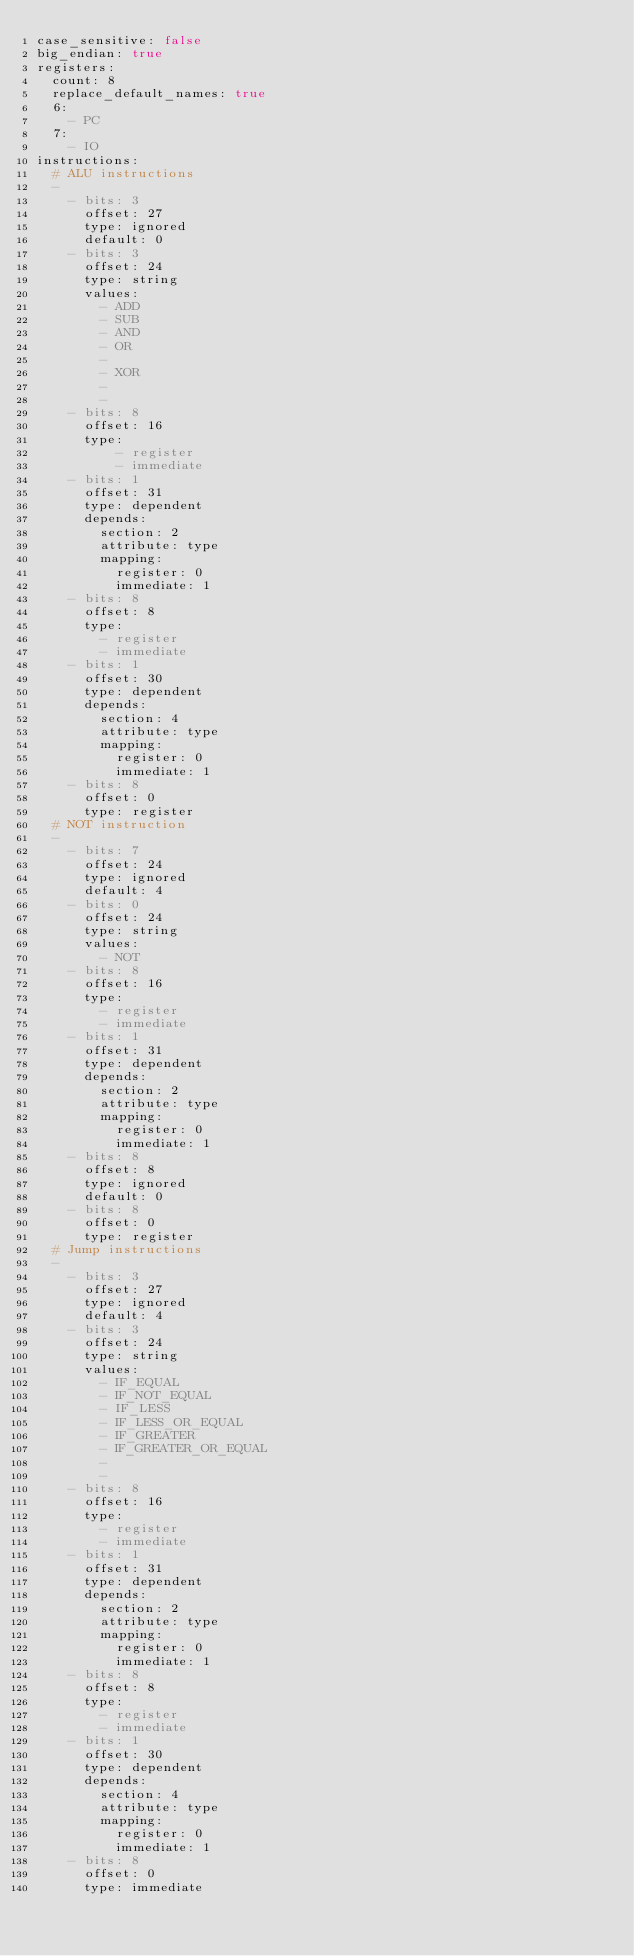<code> <loc_0><loc_0><loc_500><loc_500><_YAML_>case_sensitive: false
big_endian: true
registers:
  count: 8
  replace_default_names: true
  6:
    - PC
  7:
    - IO
instructions:
  # ALU instructions
  -
    - bits: 3
      offset: 27
      type: ignored
      default: 0
    - bits: 3
      offset: 24
      type: string
      values:
        - ADD
        - SUB
        - AND
        - OR
        -
        - XOR
        -
        -
    - bits: 8
      offset: 16
      type:
          - register
          - immediate
    - bits: 1
      offset: 31
      type: dependent
      depends:
        section: 2
        attribute: type
        mapping:
          register: 0
          immediate: 1
    - bits: 8
      offset: 8
      type:
        - register
        - immediate
    - bits: 1
      offset: 30
      type: dependent
      depends:
        section: 4
        attribute: type
        mapping:
          register: 0
          immediate: 1
    - bits: 8
      offset: 0
      type: register
  # NOT instruction
  -
    - bits: 7
      offset: 24
      type: ignored
      default: 4
    - bits: 0
      offset: 24
      type: string
      values:
        - NOT
    - bits: 8
      offset: 16
      type:
        - register
        - immediate
    - bits: 1
      offset: 31
      type: dependent
      depends:
        section: 2
        attribute: type
        mapping:
          register: 0
          immediate: 1
    - bits: 8
      offset: 8
      type: ignored
      default: 0
    - bits: 8
      offset: 0
      type: register
  # Jump instructions
  -
    - bits: 3
      offset: 27
      type: ignored
      default: 4
    - bits: 3
      offset: 24
      type: string
      values:
        - IF_EQUAL
        - IF_NOT_EQUAL
        - IF_LESS
        - IF_LESS_OR_EQUAL
        - IF_GREATER
        - IF_GREATER_OR_EQUAL
        -
        -
    - bits: 8
      offset: 16
      type:
        - register
        - immediate
    - bits: 1
      offset: 31
      type: dependent
      depends:
        section: 2
        attribute: type
        mapping:
          register: 0
          immediate: 1
    - bits: 8
      offset: 8
      type:
        - register
        - immediate
    - bits: 1
      offset: 30
      type: dependent
      depends:
        section: 4
        attribute: type
        mapping:
          register: 0
          immediate: 1
    - bits: 8
      offset: 0
      type: immediate</code> 